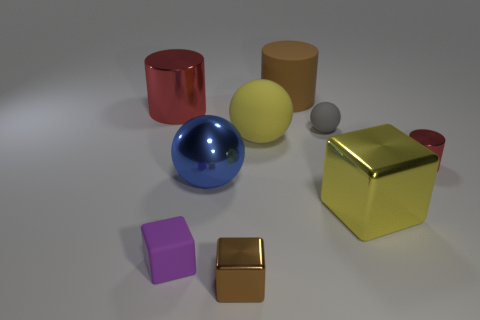There is a yellow object that is the same shape as the tiny brown shiny object; what material is it?
Offer a terse response. Metal. What is the color of the metal thing that is to the right of the large red cylinder and behind the large blue thing?
Offer a terse response. Red. The large matte sphere has what color?
Your answer should be very brief. Yellow. There is a ball that is the same color as the big cube; what material is it?
Your answer should be very brief. Rubber. Is there a small gray thing that has the same shape as the big blue shiny object?
Your answer should be very brief. Yes. There is a metallic cylinder that is on the left side of the tiny metal block; what is its size?
Give a very brief answer. Large. What is the material of the purple block that is the same size as the gray rubber object?
Your answer should be very brief. Rubber. Is the number of large yellow metallic objects greater than the number of objects?
Offer a very short reply. No. How big is the cylinder that is left of the tiny rubber thing in front of the tiny metallic cylinder?
Offer a very short reply. Large. What shape is the other matte thing that is the same size as the purple object?
Offer a very short reply. Sphere. 